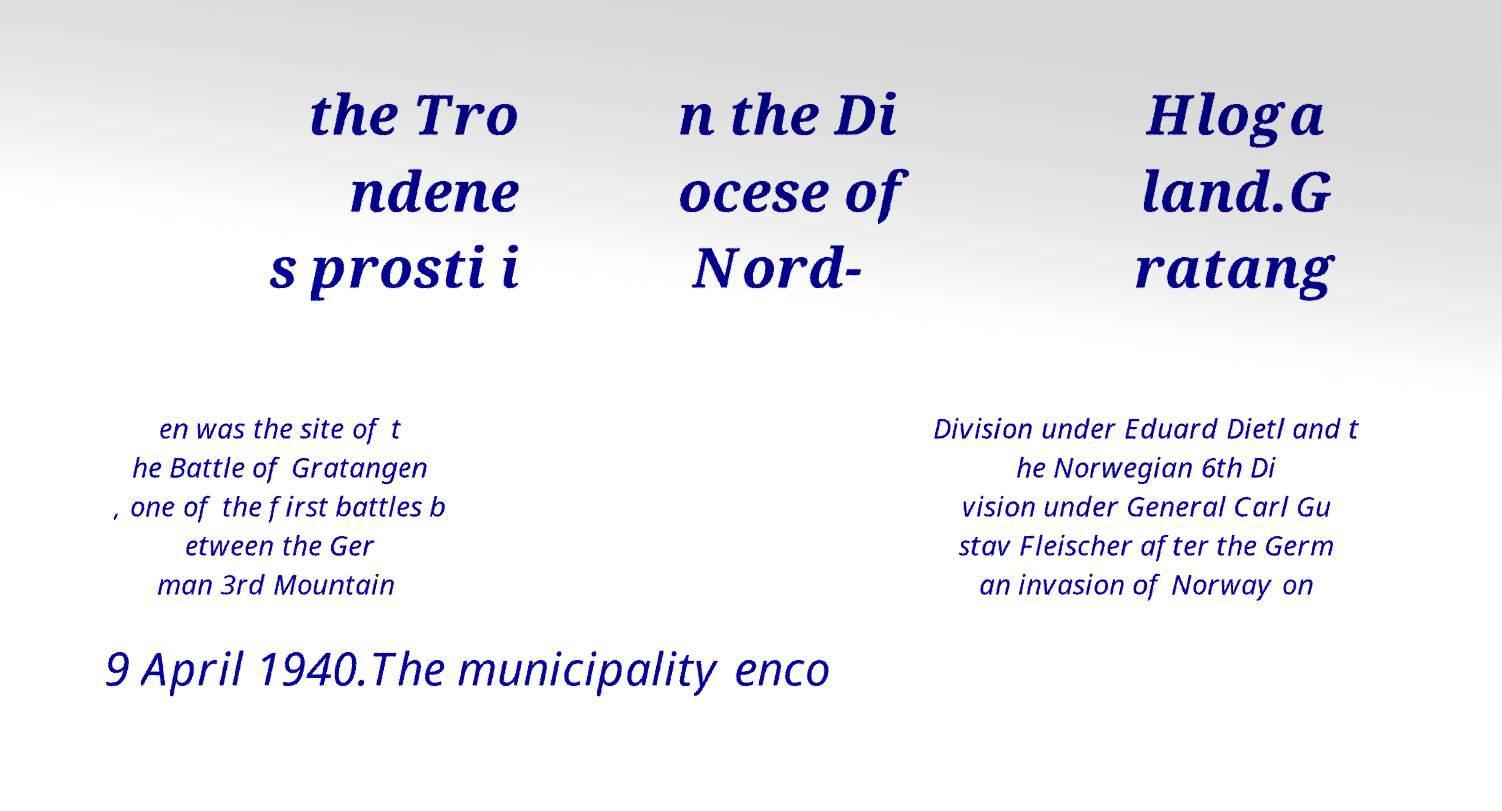Could you extract and type out the text from this image? the Tro ndene s prosti i n the Di ocese of Nord- Hloga land.G ratang en was the site of t he Battle of Gratangen , one of the first battles b etween the Ger man 3rd Mountain Division under Eduard Dietl and t he Norwegian 6th Di vision under General Carl Gu stav Fleischer after the Germ an invasion of Norway on 9 April 1940.The municipality enco 